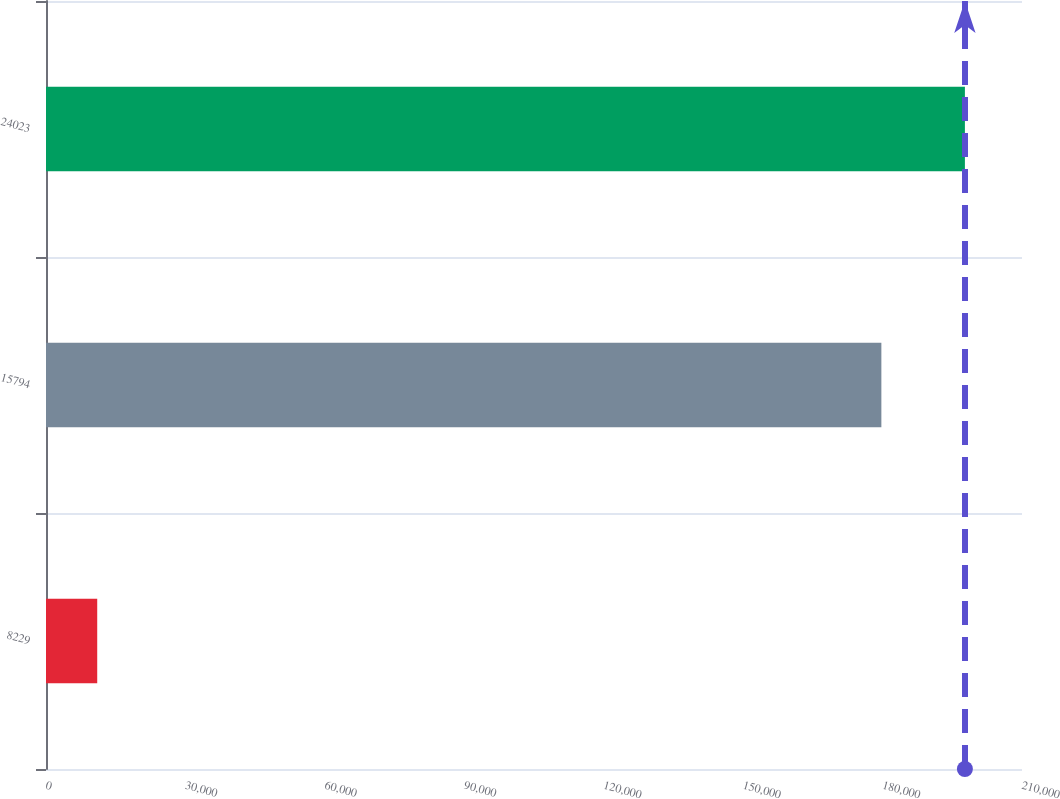Convert chart to OTSL. <chart><loc_0><loc_0><loc_500><loc_500><bar_chart><fcel>8229<fcel>15794<fcel>24023<nl><fcel>11021<fcel>179741<fcel>197715<nl></chart> 